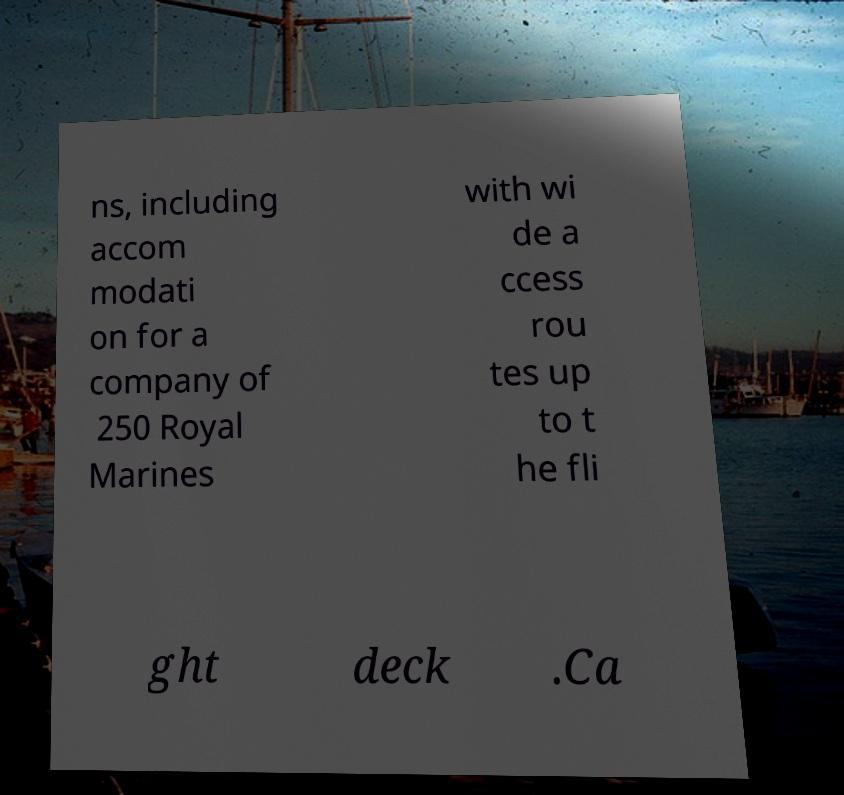Can you accurately transcribe the text from the provided image for me? ns, including accom modati on for a company of 250 Royal Marines with wi de a ccess rou tes up to t he fli ght deck .Ca 